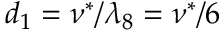<formula> <loc_0><loc_0><loc_500><loc_500>d _ { 1 } = \nu ^ { * } / \lambda _ { 8 } = \nu ^ { * } / 6</formula> 